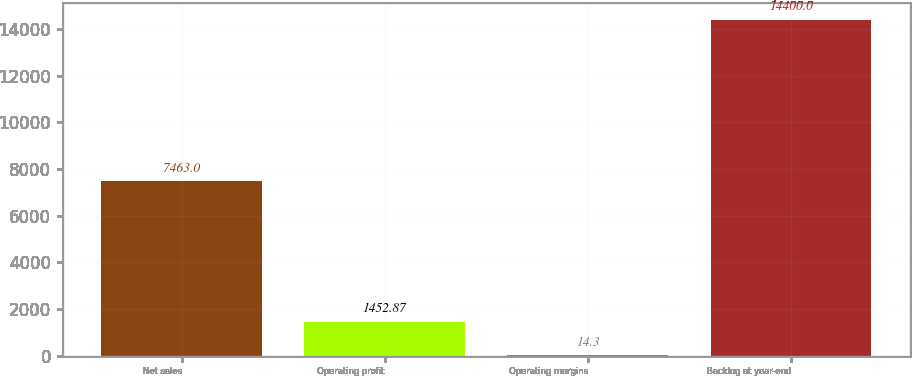Convert chart to OTSL. <chart><loc_0><loc_0><loc_500><loc_500><bar_chart><fcel>Net sales<fcel>Operating profit<fcel>Operating margins<fcel>Backlog at year-end<nl><fcel>7463<fcel>1452.87<fcel>14.3<fcel>14400<nl></chart> 